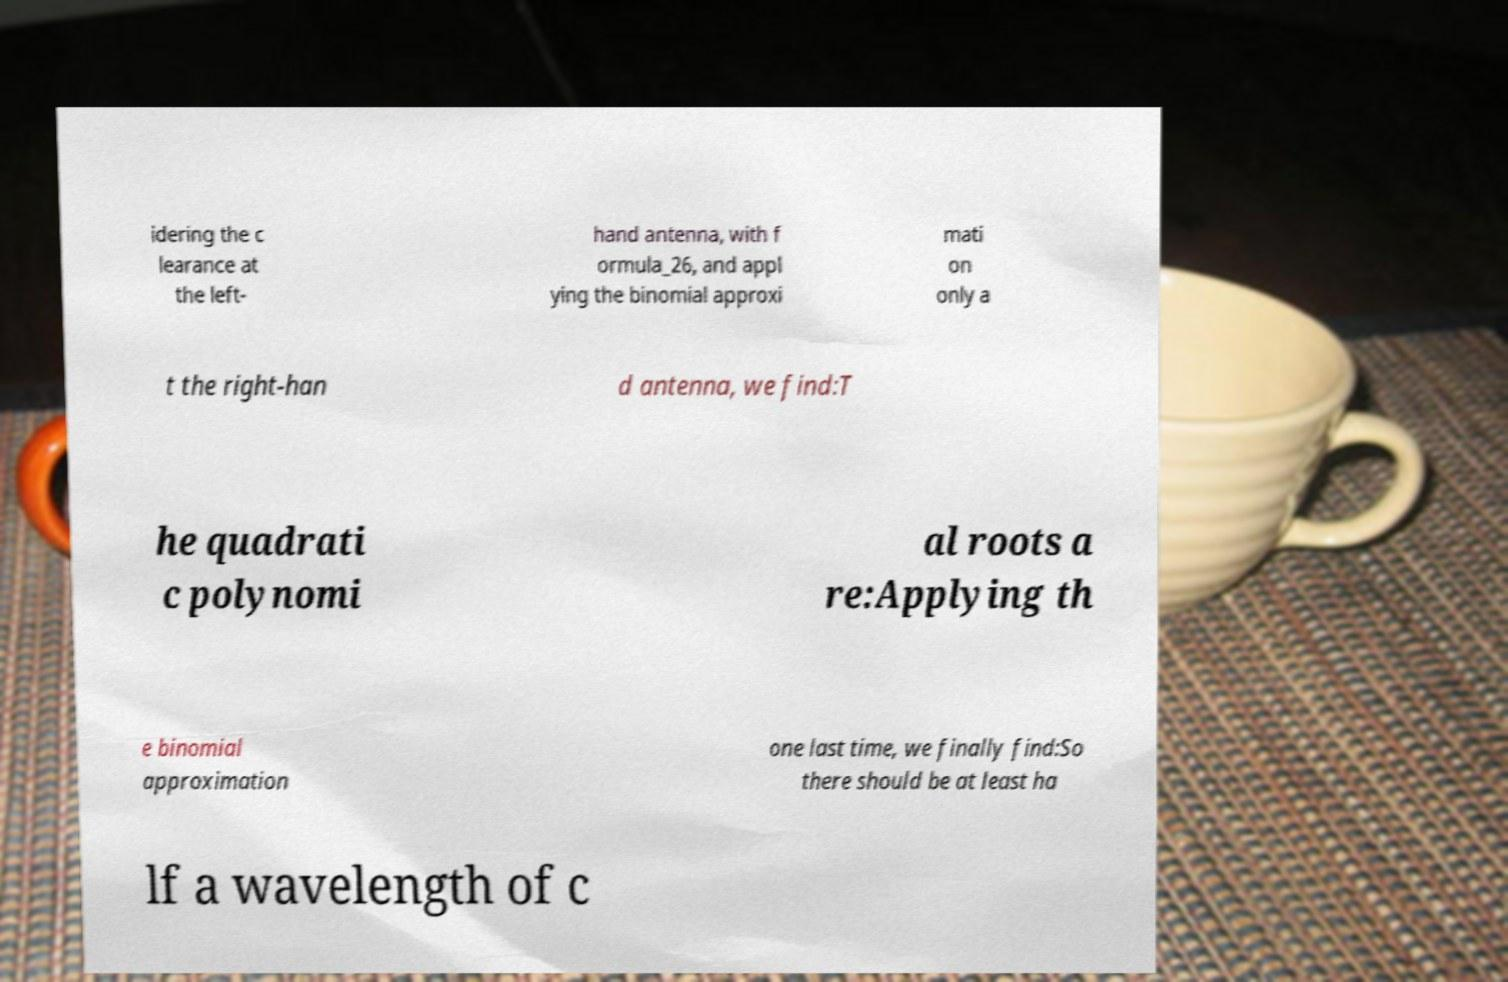There's text embedded in this image that I need extracted. Can you transcribe it verbatim? idering the c learance at the left- hand antenna, with f ormula_26, and appl ying the binomial approxi mati on only a t the right-han d antenna, we find:T he quadrati c polynomi al roots a re:Applying th e binomial approximation one last time, we finally find:So there should be at least ha lf a wavelength of c 